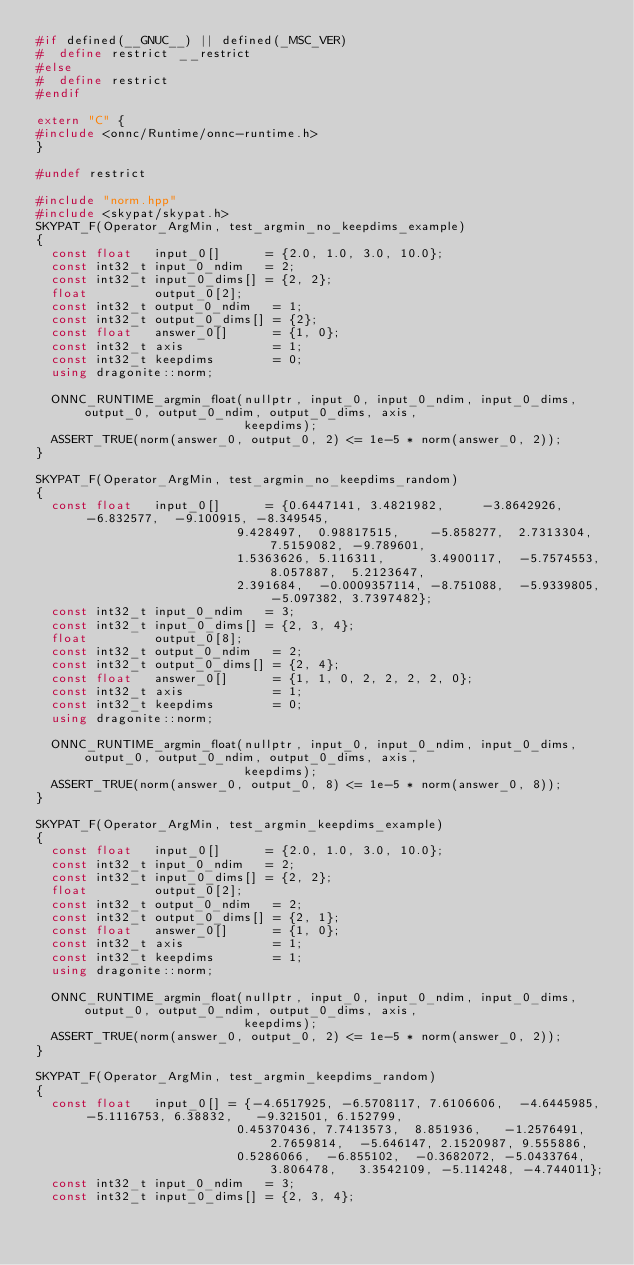<code> <loc_0><loc_0><loc_500><loc_500><_C++_>#if defined(__GNUC__) || defined(_MSC_VER)
#  define restrict __restrict
#else
#  define restrict
#endif

extern "C" {
#include <onnc/Runtime/onnc-runtime.h>
}

#undef restrict

#include "norm.hpp"
#include <skypat/skypat.h>
SKYPAT_F(Operator_ArgMin, test_argmin_no_keepdims_example)
{
  const float   input_0[]      = {2.0, 1.0, 3.0, 10.0};
  const int32_t input_0_ndim   = 2;
  const int32_t input_0_dims[] = {2, 2};
  float         output_0[2];
  const int32_t output_0_ndim   = 1;
  const int32_t output_0_dims[] = {2};
  const float   answer_0[]      = {1, 0};
  const int32_t axis            = 1;
  const int32_t keepdims        = 0;
  using dragonite::norm;

  ONNC_RUNTIME_argmin_float(nullptr, input_0, input_0_ndim, input_0_dims, output_0, output_0_ndim, output_0_dims, axis,
                            keepdims);
  ASSERT_TRUE(norm(answer_0, output_0, 2) <= 1e-5 * norm(answer_0, 2));
}

SKYPAT_F(Operator_ArgMin, test_argmin_no_keepdims_random)
{
  const float   input_0[]      = {0.6447141, 3.4821982,     -3.8642926, -6.832577,  -9.100915, -8.349545,
                           9.428497,  0.98817515,    -5.858277,  2.7313304,  7.5159082, -9.789601,
                           1.5363626, 5.116311,      3.4900117,  -5.7574553, 8.057887,  5.2123647,
                           2.391684,  -0.0009357114, -8.751088,  -5.9339805, -5.097382, 3.7397482};
  const int32_t input_0_ndim   = 3;
  const int32_t input_0_dims[] = {2, 3, 4};
  float         output_0[8];
  const int32_t output_0_ndim   = 2;
  const int32_t output_0_dims[] = {2, 4};
  const float   answer_0[]      = {1, 1, 0, 2, 2, 2, 2, 0};
  const int32_t axis            = 1;
  const int32_t keepdims        = 0;
  using dragonite::norm;

  ONNC_RUNTIME_argmin_float(nullptr, input_0, input_0_ndim, input_0_dims, output_0, output_0_ndim, output_0_dims, axis,
                            keepdims);
  ASSERT_TRUE(norm(answer_0, output_0, 8) <= 1e-5 * norm(answer_0, 8));
}

SKYPAT_F(Operator_ArgMin, test_argmin_keepdims_example)
{
  const float   input_0[]      = {2.0, 1.0, 3.0, 10.0};
  const int32_t input_0_ndim   = 2;
  const int32_t input_0_dims[] = {2, 2};
  float         output_0[2];
  const int32_t output_0_ndim   = 2;
  const int32_t output_0_dims[] = {2, 1};
  const float   answer_0[]      = {1, 0};
  const int32_t axis            = 1;
  const int32_t keepdims        = 1;
  using dragonite::norm;

  ONNC_RUNTIME_argmin_float(nullptr, input_0, input_0_ndim, input_0_dims, output_0, output_0_ndim, output_0_dims, axis,
                            keepdims);
  ASSERT_TRUE(norm(answer_0, output_0, 2) <= 1e-5 * norm(answer_0, 2));
}

SKYPAT_F(Operator_ArgMin, test_argmin_keepdims_random)
{
  const float   input_0[] = {-4.6517925, -6.5708117, 7.6106606,  -4.6445985, -5.1116753, 6.38832,   -9.321501, 6.152799,
                           0.45370436, 7.7413573,  8.851936,   -1.2576491, 2.7659814,  -5.646147, 2.1520987, 9.555886,
                           0.5286066,  -6.855102,  -0.3682072, -5.0433764, 3.806478,   3.3542109, -5.114248, -4.744011};
  const int32_t input_0_ndim   = 3;
  const int32_t input_0_dims[] = {2, 3, 4};</code> 